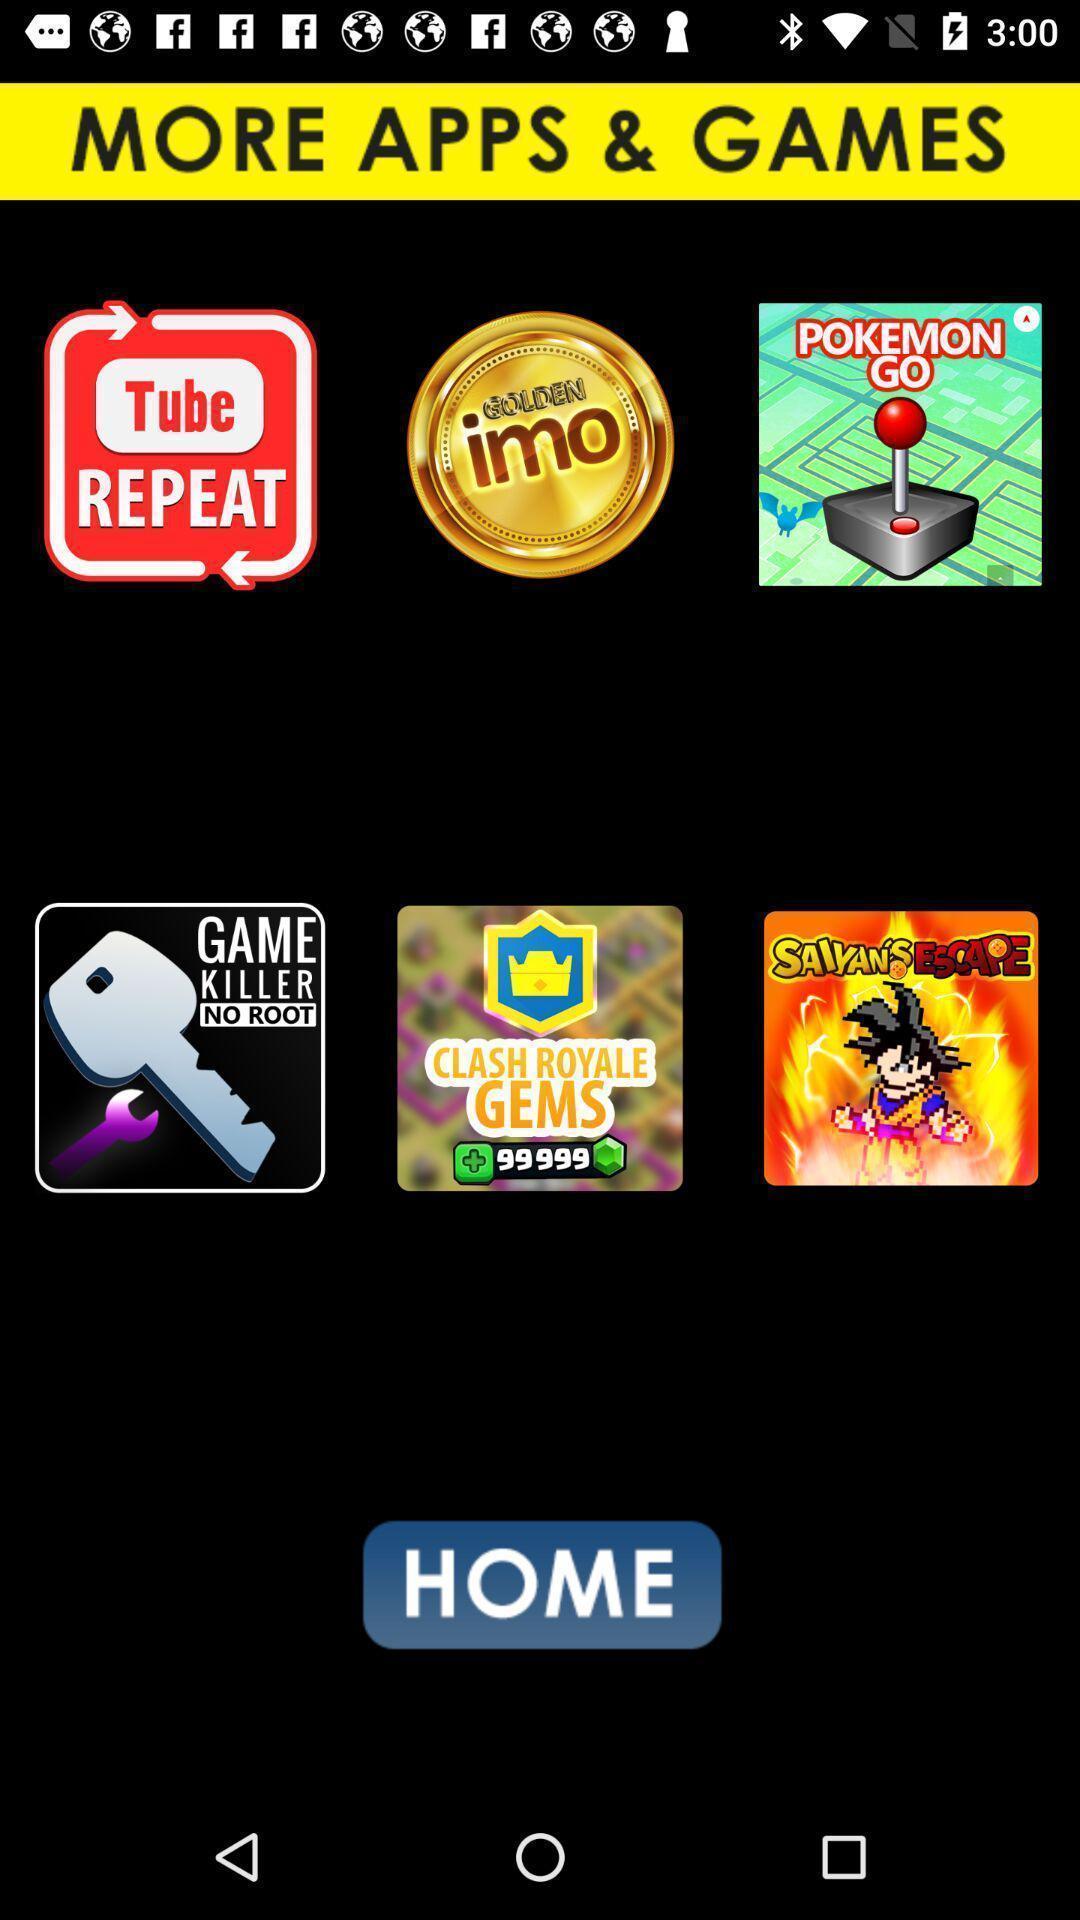What details can you identify in this image? Page displaying more app and games with a home button. 